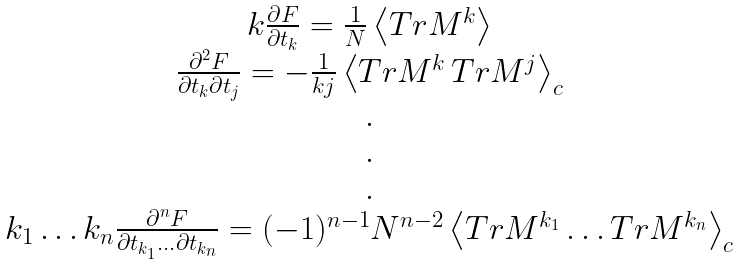Convert formula to latex. <formula><loc_0><loc_0><loc_500><loc_500>\begin{array} { c } k \frac { \partial F } { \partial t _ { k } } = \frac { 1 } { N } \left \langle T r M ^ { k } \right \rangle \\ \frac { \partial ^ { 2 } F } { \partial t _ { k } \partial t _ { j } } = - \frac { 1 } { k j } \left \langle T r M ^ { k } \, T r M ^ { j } \right \rangle _ { c } \\ . \\ . \\ . \\ k _ { 1 } \dots k _ { n } \frac { \partial ^ { n } F } { \partial t _ { k _ { 1 } } \dots \partial t _ { k _ { n } } } = ( - 1 ) ^ { n - 1 } N ^ { n - 2 } \left \langle T r M ^ { k _ { 1 } } \dots T r M ^ { k _ { n } } \right \rangle _ { c } \\ \end{array}</formula> 